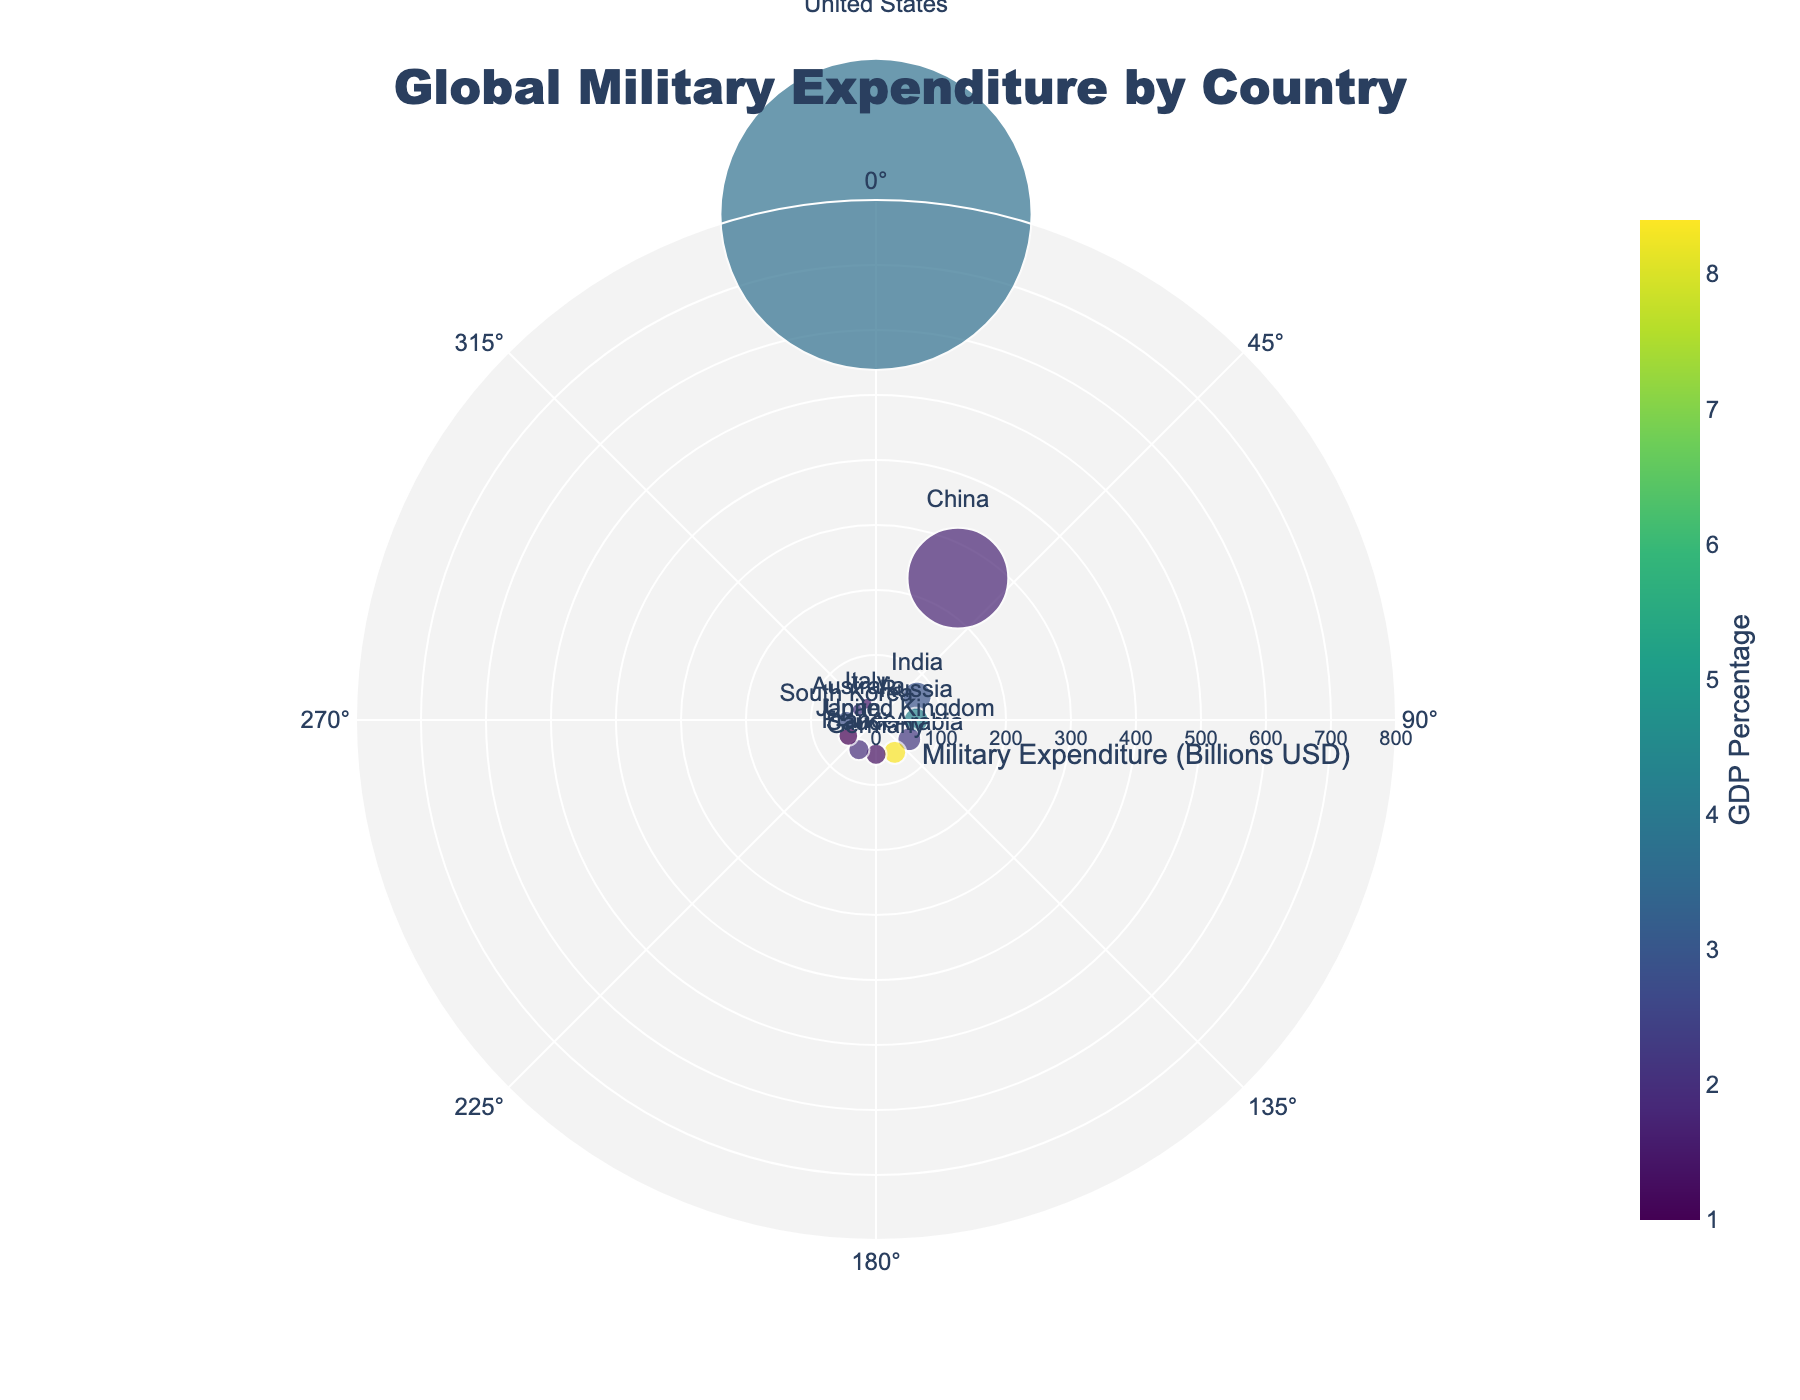What is the title of the figure? The figure title is centered at the top. It reads "Global Military Expenditure by Country."
Answer: Global Military Expenditure by Country How many countries are represented in the figure? By counting the number of data points (scatter markers with country names), we see there are 12 countries listed.
Answer: 12 Which country has the highest military expenditure? By looking at the length of the radial lines, the United States has the longest line, indicating the highest military expenditure at $778 billion.
Answer: United States Which country allocates the highest percentage of its GDP to military expenditure? The color scale indicates GDP percentages. Saudi Arabia is the darkest, denoting the highest GDP percentage at 8.4%.
Answer: Saudi Arabia What is the military expenditure of China? The radial line for China is located at the 30-degree angle and intersects at $252 billion.
Answer: $252 billion How do the military expenditures of Germany and France compare? Germany's radial line is at 180 degrees with $52.8 billion and France at 210 degrees with $52.7 billion. Germany spends slightly more than France on its military.
Answer: Germany spends slightly more What percentage of GDP does Japan spend on its military? By hovering over the data point for Japan at the 240-degree angle, the hovertext shows Japan’s GDP percentage for military expenditure is 1.0%.
Answer: 1.0% What is the sum of military expenditures of Russia and the United Kingdom? Russia spends $61.7 billion and the United Kingdom spends $59.2 billion. Adding these values gives a sum of $120.9 billion.
Answer: $120.9 billion Which countries have a military expenditure of more than $50 billion but less than $100 billion? Countries within the $50 billion to $100 billion radial range are India ($72.9 billion), Russia ($61.7 billion), United Kingdom ($59.2 billion), Germany ($52.8 billion), and France ($52.7 billion).
Answer: India, Russia, United Kingdom, Germany, France What is the average GDP percentage allocated to military expenditure for the countries in the chart? Summing the GDP percentages for all listed countries (3.7+1.7+2.9+4.3+2.2+8.4+1.3+2.0+1.0+2.8+2.1+1.5) gives 33.9. Dividing this by the number of countries (12) gives an average of approximately 2.83%.
Answer: ~2.83% 